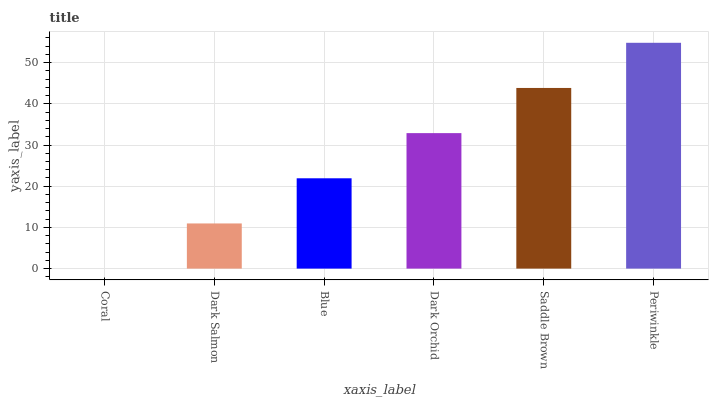Is Coral the minimum?
Answer yes or no. Yes. Is Periwinkle the maximum?
Answer yes or no. Yes. Is Dark Salmon the minimum?
Answer yes or no. No. Is Dark Salmon the maximum?
Answer yes or no. No. Is Dark Salmon greater than Coral?
Answer yes or no. Yes. Is Coral less than Dark Salmon?
Answer yes or no. Yes. Is Coral greater than Dark Salmon?
Answer yes or no. No. Is Dark Salmon less than Coral?
Answer yes or no. No. Is Dark Orchid the high median?
Answer yes or no. Yes. Is Blue the low median?
Answer yes or no. Yes. Is Blue the high median?
Answer yes or no. No. Is Coral the low median?
Answer yes or no. No. 